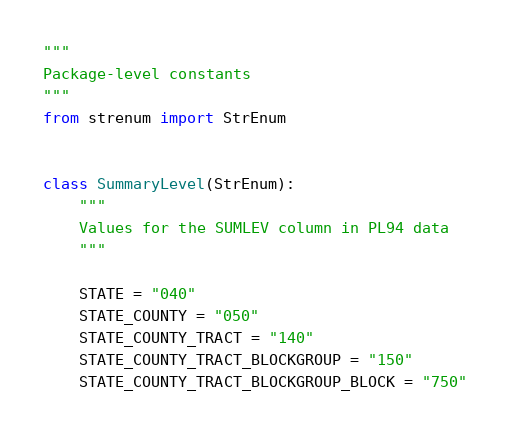<code> <loc_0><loc_0><loc_500><loc_500><_Python_>"""
Package-level constants
"""
from strenum import StrEnum


class SummaryLevel(StrEnum):
    """
    Values for the SUMLEV column in PL94 data
    """

    STATE = "040"
    STATE_COUNTY = "050"
    STATE_COUNTY_TRACT = "140"
    STATE_COUNTY_TRACT_BLOCKGROUP = "150"
    STATE_COUNTY_TRACT_BLOCKGROUP_BLOCK = "750"
</code> 